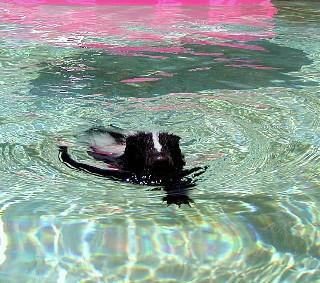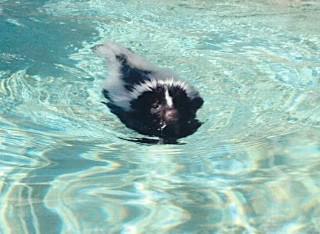The first image is the image on the left, the second image is the image on the right. Analyze the images presented: Is the assertion "In at least one image there is a skunk sitting on a blue raft in a pool." valid? Answer yes or no. No. The first image is the image on the left, the second image is the image on the right. Given the left and right images, does the statement "The skunk in one of the images is sitting on a float in a pool, while in the other image it is swimming freely in the water." hold true? Answer yes or no. No. 